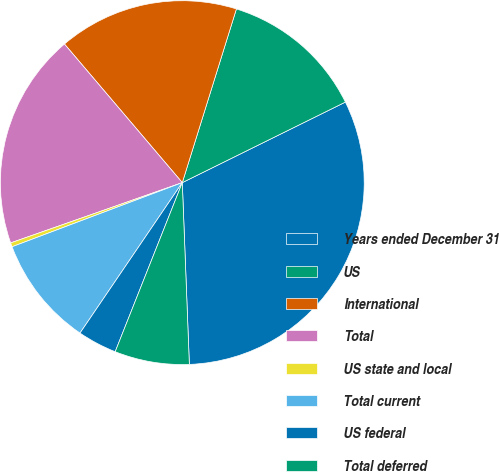<chart> <loc_0><loc_0><loc_500><loc_500><pie_chart><fcel>Years ended December 31<fcel>US<fcel>International<fcel>Total<fcel>US state and local<fcel>Total current<fcel>US federal<fcel>Total deferred<nl><fcel>31.68%<fcel>12.89%<fcel>16.02%<fcel>19.16%<fcel>0.36%<fcel>9.76%<fcel>3.49%<fcel>6.63%<nl></chart> 